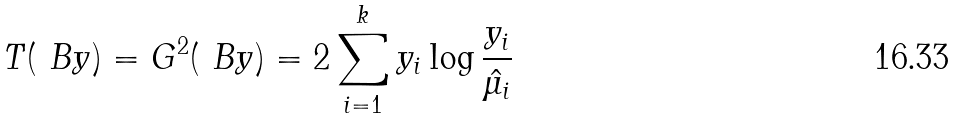<formula> <loc_0><loc_0><loc_500><loc_500>T ( \ B y ) = G ^ { 2 } ( \ B y ) = 2 \sum _ { i = 1 } ^ { k } y _ { i } \log \frac { y _ { i } } { \hat { \mu _ { i } } }</formula> 